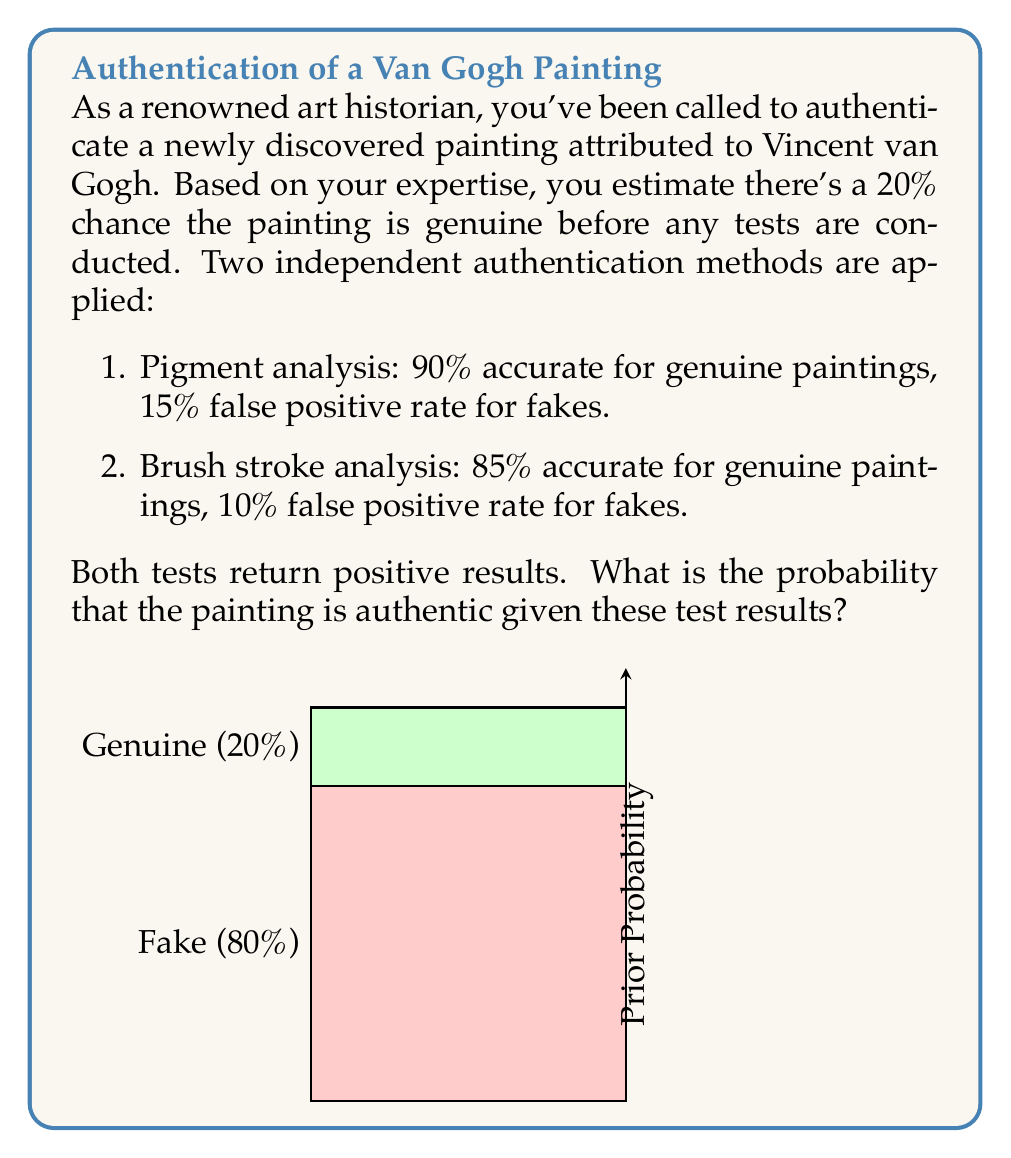Give your solution to this math problem. Let's approach this problem using Bayes' theorem. We'll denote:

A: The painting is authentic
P: Positive result from pigment analysis
B: Positive result from brush stroke analysis

Given:
$P(A) = 0.2$ (prior probability)
$P(P|A) = 0.9$, $P(P|\neg A) = 0.15$
$P(B|A) = 0.85$, $P(B|\neg A) = 0.1$

We want to find $P(A|P,B)$. Using Bayes' theorem:

$$P(A|P,B) = \frac{P(P,B|A) \cdot P(A)}{P(P,B)}$$

1) First, calculate $P(P,B|A)$:
   $P(P,B|A) = P(P|A) \cdot P(B|A) = 0.9 \cdot 0.85 = 0.765$

2) Use the law of total probability to calculate $P(P,B)$:
   $P(P,B) = P(P,B|A) \cdot P(A) + P(P,B|\neg A) \cdot P(\neg A)$
   $= 0.765 \cdot 0.2 + (0.15 \cdot 0.1) \cdot 0.8 = 0.153 + 0.012 = 0.165$

3) Now we can apply Bayes' theorem:
   $$P(A|P,B) = \frac{0.765 \cdot 0.2}{0.165} \approx 0.9273$$

Therefore, the probability that the painting is authentic given the positive test results is approximately 92.73%.
Answer: $P(A|P,B) \approx 0.9273$ or $92.73\%$ 